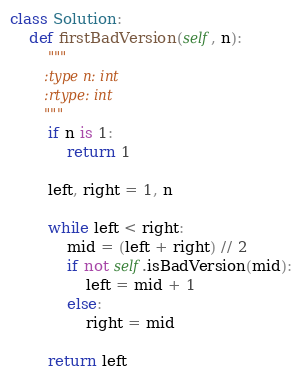Convert code to text. <code><loc_0><loc_0><loc_500><loc_500><_Python_>
class Solution:
    def firstBadVersion(self, n):
        """
        :type n: int
        :rtype: int
        """
        if n is 1:
            return 1

        left, right = 1, n

        while left < right:
            mid = (left + right) // 2
            if not self.isBadVersion(mid):
                left = mid + 1
            else:
                right = mid

        return left
</code> 